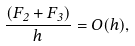Convert formula to latex. <formula><loc_0><loc_0><loc_500><loc_500>\frac { ( F _ { 2 } + F _ { 3 } ) } h = O ( h ) ,</formula> 